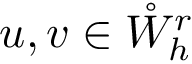Convert formula to latex. <formula><loc_0><loc_0><loc_500><loc_500>u , v \in \mathring { W } _ { h } ^ { r }</formula> 